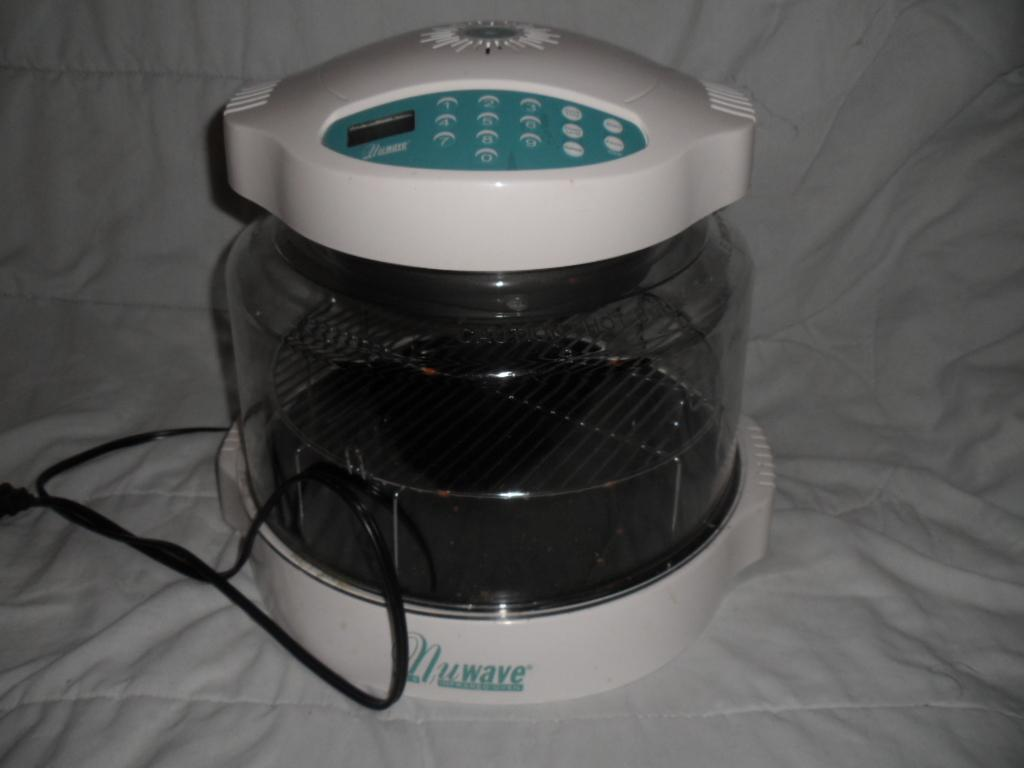<image>
Create a compact narrative representing the image presented. A black and white Nuwave fryer on a white cloth 